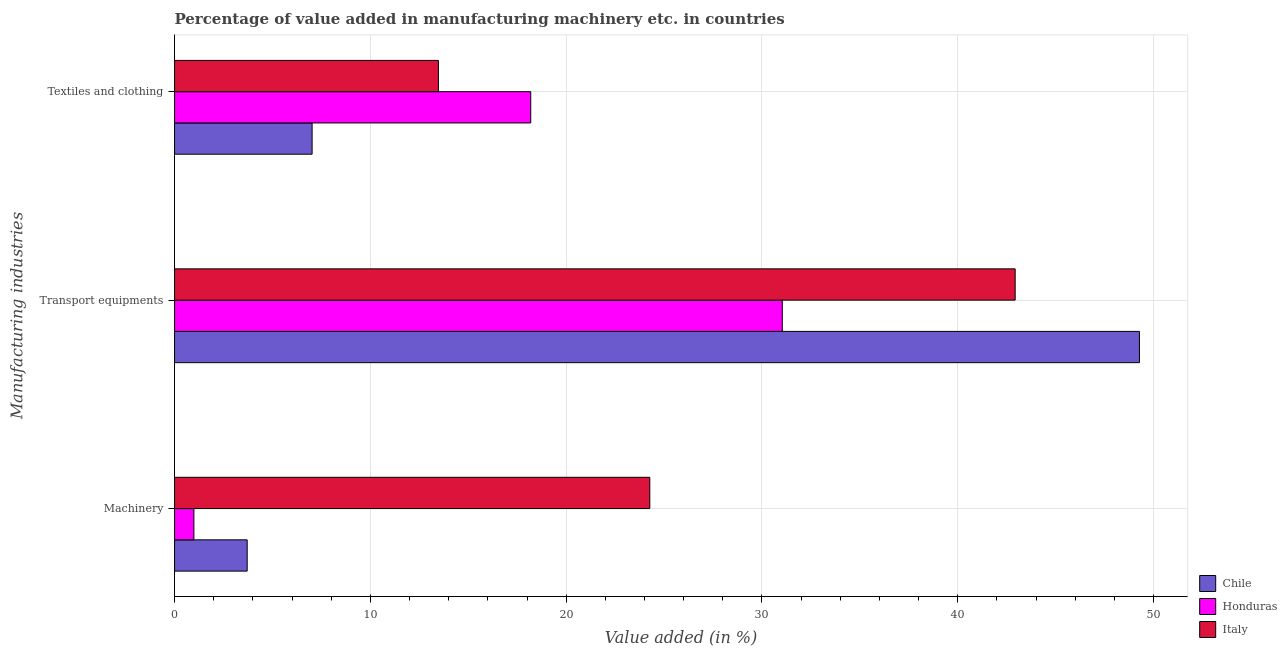How many different coloured bars are there?
Provide a short and direct response. 3. How many groups of bars are there?
Ensure brevity in your answer.  3. How many bars are there on the 1st tick from the top?
Your answer should be very brief. 3. What is the label of the 2nd group of bars from the top?
Offer a very short reply. Transport equipments. What is the value added in manufacturing transport equipments in Chile?
Make the answer very short. 49.28. Across all countries, what is the maximum value added in manufacturing machinery?
Offer a terse response. 24.27. Across all countries, what is the minimum value added in manufacturing machinery?
Your response must be concise. 0.99. In which country was the value added in manufacturing machinery minimum?
Your answer should be very brief. Honduras. What is the total value added in manufacturing machinery in the graph?
Your answer should be compact. 28.97. What is the difference between the value added in manufacturing transport equipments in Italy and that in Chile?
Provide a succinct answer. -6.35. What is the difference between the value added in manufacturing textile and clothing in Honduras and the value added in manufacturing machinery in Italy?
Ensure brevity in your answer.  -6.08. What is the average value added in manufacturing transport equipments per country?
Your answer should be very brief. 41.08. What is the difference between the value added in manufacturing textile and clothing and value added in manufacturing machinery in Chile?
Make the answer very short. 3.32. In how many countries, is the value added in manufacturing transport equipments greater than 46 %?
Provide a succinct answer. 1. What is the ratio of the value added in manufacturing textile and clothing in Chile to that in Italy?
Give a very brief answer. 0.52. Is the value added in manufacturing transport equipments in Honduras less than that in Chile?
Make the answer very short. Yes. Is the difference between the value added in manufacturing machinery in Honduras and Chile greater than the difference between the value added in manufacturing transport equipments in Honduras and Chile?
Your answer should be very brief. Yes. What is the difference between the highest and the second highest value added in manufacturing transport equipments?
Ensure brevity in your answer.  6.35. What is the difference between the highest and the lowest value added in manufacturing transport equipments?
Keep it short and to the point. 18.24. Is the sum of the value added in manufacturing machinery in Italy and Chile greater than the maximum value added in manufacturing transport equipments across all countries?
Provide a succinct answer. No. What does the 1st bar from the top in Machinery represents?
Your answer should be compact. Italy. How many countries are there in the graph?
Offer a very short reply. 3. Where does the legend appear in the graph?
Provide a short and direct response. Bottom right. What is the title of the graph?
Give a very brief answer. Percentage of value added in manufacturing machinery etc. in countries. What is the label or title of the X-axis?
Keep it short and to the point. Value added (in %). What is the label or title of the Y-axis?
Make the answer very short. Manufacturing industries. What is the Value added (in %) in Chile in Machinery?
Provide a succinct answer. 3.71. What is the Value added (in %) of Honduras in Machinery?
Provide a short and direct response. 0.99. What is the Value added (in %) of Italy in Machinery?
Keep it short and to the point. 24.27. What is the Value added (in %) in Chile in Transport equipments?
Make the answer very short. 49.28. What is the Value added (in %) of Honduras in Transport equipments?
Provide a short and direct response. 31.04. What is the Value added (in %) of Italy in Transport equipments?
Give a very brief answer. 42.93. What is the Value added (in %) of Chile in Textiles and clothing?
Give a very brief answer. 7.03. What is the Value added (in %) in Honduras in Textiles and clothing?
Keep it short and to the point. 18.19. What is the Value added (in %) of Italy in Textiles and clothing?
Give a very brief answer. 13.48. Across all Manufacturing industries, what is the maximum Value added (in %) of Chile?
Your response must be concise. 49.28. Across all Manufacturing industries, what is the maximum Value added (in %) of Honduras?
Make the answer very short. 31.04. Across all Manufacturing industries, what is the maximum Value added (in %) of Italy?
Ensure brevity in your answer.  42.93. Across all Manufacturing industries, what is the minimum Value added (in %) in Chile?
Your answer should be very brief. 3.71. Across all Manufacturing industries, what is the minimum Value added (in %) in Honduras?
Your answer should be compact. 0.99. Across all Manufacturing industries, what is the minimum Value added (in %) of Italy?
Provide a succinct answer. 13.48. What is the total Value added (in %) of Chile in the graph?
Offer a terse response. 60.01. What is the total Value added (in %) of Honduras in the graph?
Your answer should be compact. 50.22. What is the total Value added (in %) in Italy in the graph?
Your answer should be very brief. 80.68. What is the difference between the Value added (in %) of Chile in Machinery and that in Transport equipments?
Your answer should be compact. -45.57. What is the difference between the Value added (in %) in Honduras in Machinery and that in Transport equipments?
Offer a very short reply. -30.05. What is the difference between the Value added (in %) of Italy in Machinery and that in Transport equipments?
Your response must be concise. -18.66. What is the difference between the Value added (in %) in Chile in Machinery and that in Textiles and clothing?
Keep it short and to the point. -3.32. What is the difference between the Value added (in %) of Honduras in Machinery and that in Textiles and clothing?
Keep it short and to the point. -17.2. What is the difference between the Value added (in %) of Italy in Machinery and that in Textiles and clothing?
Keep it short and to the point. 10.8. What is the difference between the Value added (in %) in Chile in Transport equipments and that in Textiles and clothing?
Offer a very short reply. 42.25. What is the difference between the Value added (in %) in Honduras in Transport equipments and that in Textiles and clothing?
Offer a terse response. 12.85. What is the difference between the Value added (in %) of Italy in Transport equipments and that in Textiles and clothing?
Keep it short and to the point. 29.46. What is the difference between the Value added (in %) in Chile in Machinery and the Value added (in %) in Honduras in Transport equipments?
Your answer should be very brief. -27.33. What is the difference between the Value added (in %) in Chile in Machinery and the Value added (in %) in Italy in Transport equipments?
Provide a short and direct response. -39.22. What is the difference between the Value added (in %) of Honduras in Machinery and the Value added (in %) of Italy in Transport equipments?
Your answer should be very brief. -41.94. What is the difference between the Value added (in %) in Chile in Machinery and the Value added (in %) in Honduras in Textiles and clothing?
Provide a succinct answer. -14.48. What is the difference between the Value added (in %) of Chile in Machinery and the Value added (in %) of Italy in Textiles and clothing?
Make the answer very short. -9.77. What is the difference between the Value added (in %) of Honduras in Machinery and the Value added (in %) of Italy in Textiles and clothing?
Offer a terse response. -12.49. What is the difference between the Value added (in %) of Chile in Transport equipments and the Value added (in %) of Honduras in Textiles and clothing?
Offer a terse response. 31.09. What is the difference between the Value added (in %) in Chile in Transport equipments and the Value added (in %) in Italy in Textiles and clothing?
Your response must be concise. 35.8. What is the difference between the Value added (in %) in Honduras in Transport equipments and the Value added (in %) in Italy in Textiles and clothing?
Give a very brief answer. 17.56. What is the average Value added (in %) in Chile per Manufacturing industries?
Make the answer very short. 20. What is the average Value added (in %) of Honduras per Manufacturing industries?
Your response must be concise. 16.74. What is the average Value added (in %) in Italy per Manufacturing industries?
Provide a short and direct response. 26.89. What is the difference between the Value added (in %) in Chile and Value added (in %) in Honduras in Machinery?
Provide a short and direct response. 2.72. What is the difference between the Value added (in %) of Chile and Value added (in %) of Italy in Machinery?
Give a very brief answer. -20.56. What is the difference between the Value added (in %) of Honduras and Value added (in %) of Italy in Machinery?
Give a very brief answer. -23.28. What is the difference between the Value added (in %) of Chile and Value added (in %) of Honduras in Transport equipments?
Offer a very short reply. 18.24. What is the difference between the Value added (in %) in Chile and Value added (in %) in Italy in Transport equipments?
Offer a very short reply. 6.35. What is the difference between the Value added (in %) in Honduras and Value added (in %) in Italy in Transport equipments?
Keep it short and to the point. -11.89. What is the difference between the Value added (in %) of Chile and Value added (in %) of Honduras in Textiles and clothing?
Give a very brief answer. -11.17. What is the difference between the Value added (in %) in Chile and Value added (in %) in Italy in Textiles and clothing?
Provide a short and direct response. -6.45. What is the difference between the Value added (in %) in Honduras and Value added (in %) in Italy in Textiles and clothing?
Your response must be concise. 4.72. What is the ratio of the Value added (in %) of Chile in Machinery to that in Transport equipments?
Keep it short and to the point. 0.08. What is the ratio of the Value added (in %) in Honduras in Machinery to that in Transport equipments?
Provide a short and direct response. 0.03. What is the ratio of the Value added (in %) in Italy in Machinery to that in Transport equipments?
Ensure brevity in your answer.  0.57. What is the ratio of the Value added (in %) in Chile in Machinery to that in Textiles and clothing?
Your response must be concise. 0.53. What is the ratio of the Value added (in %) in Honduras in Machinery to that in Textiles and clothing?
Your answer should be very brief. 0.05. What is the ratio of the Value added (in %) of Italy in Machinery to that in Textiles and clothing?
Ensure brevity in your answer.  1.8. What is the ratio of the Value added (in %) of Chile in Transport equipments to that in Textiles and clothing?
Your response must be concise. 7.01. What is the ratio of the Value added (in %) of Honduras in Transport equipments to that in Textiles and clothing?
Keep it short and to the point. 1.71. What is the ratio of the Value added (in %) in Italy in Transport equipments to that in Textiles and clothing?
Give a very brief answer. 3.19. What is the difference between the highest and the second highest Value added (in %) in Chile?
Give a very brief answer. 42.25. What is the difference between the highest and the second highest Value added (in %) of Honduras?
Provide a short and direct response. 12.85. What is the difference between the highest and the second highest Value added (in %) in Italy?
Give a very brief answer. 18.66. What is the difference between the highest and the lowest Value added (in %) in Chile?
Offer a terse response. 45.57. What is the difference between the highest and the lowest Value added (in %) in Honduras?
Give a very brief answer. 30.05. What is the difference between the highest and the lowest Value added (in %) of Italy?
Offer a very short reply. 29.46. 